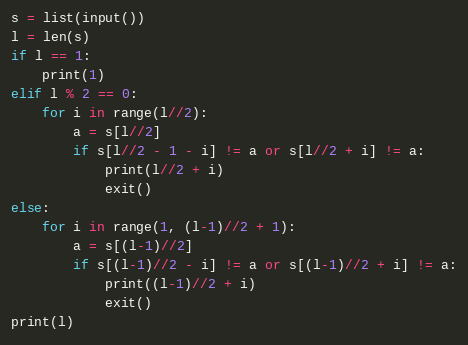Convert code to text. <code><loc_0><loc_0><loc_500><loc_500><_Python_>s = list(input())
l = len(s)
if l == 1:
    print(1)
elif l % 2 == 0:
    for i in range(l//2):
        a = s[l//2]
        if s[l//2 - 1 - i] != a or s[l//2 + i] != a:
            print(l//2 + i)
            exit()
else:
    for i in range(1, (l-1)//2 + 1):
        a = s[(l-1)//2]
        if s[(l-1)//2 - i] != a or s[(l-1)//2 + i] != a:
            print((l-1)//2 + i)
            exit()
print(l)</code> 